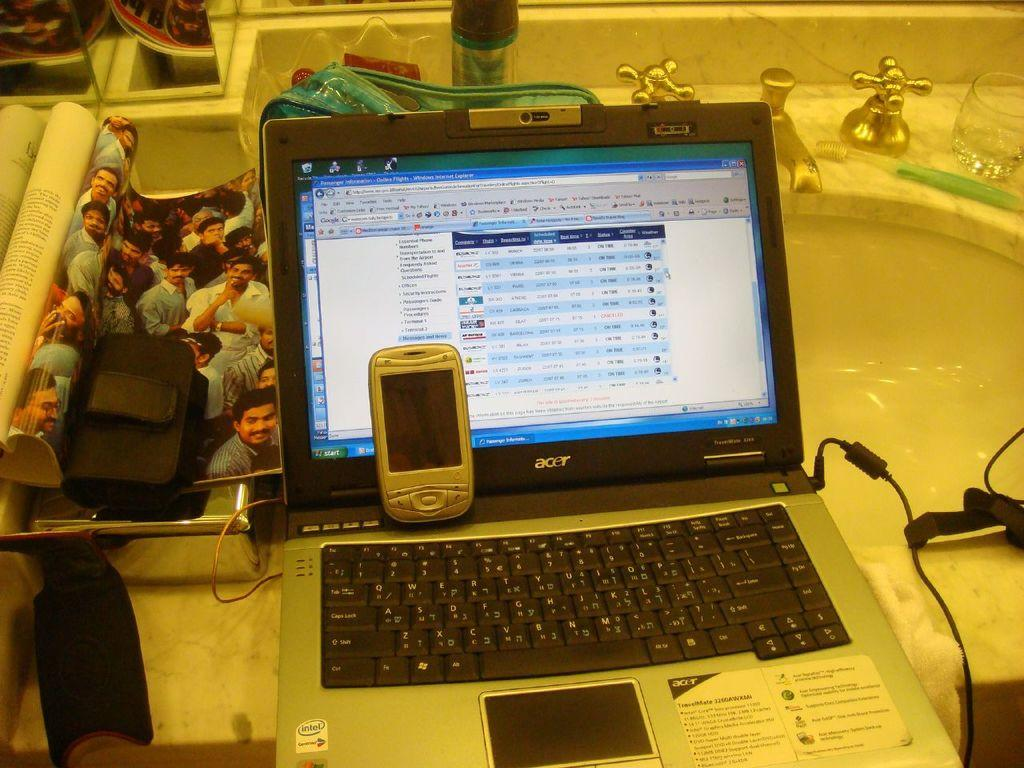Provide a one-sentence caption for the provided image. An Acer laptop is open and sitting on a bathroom sink. 